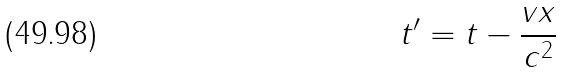<formula> <loc_0><loc_0><loc_500><loc_500>t ^ { \prime } = t - \frac { v x } { c ^ { 2 } }</formula> 